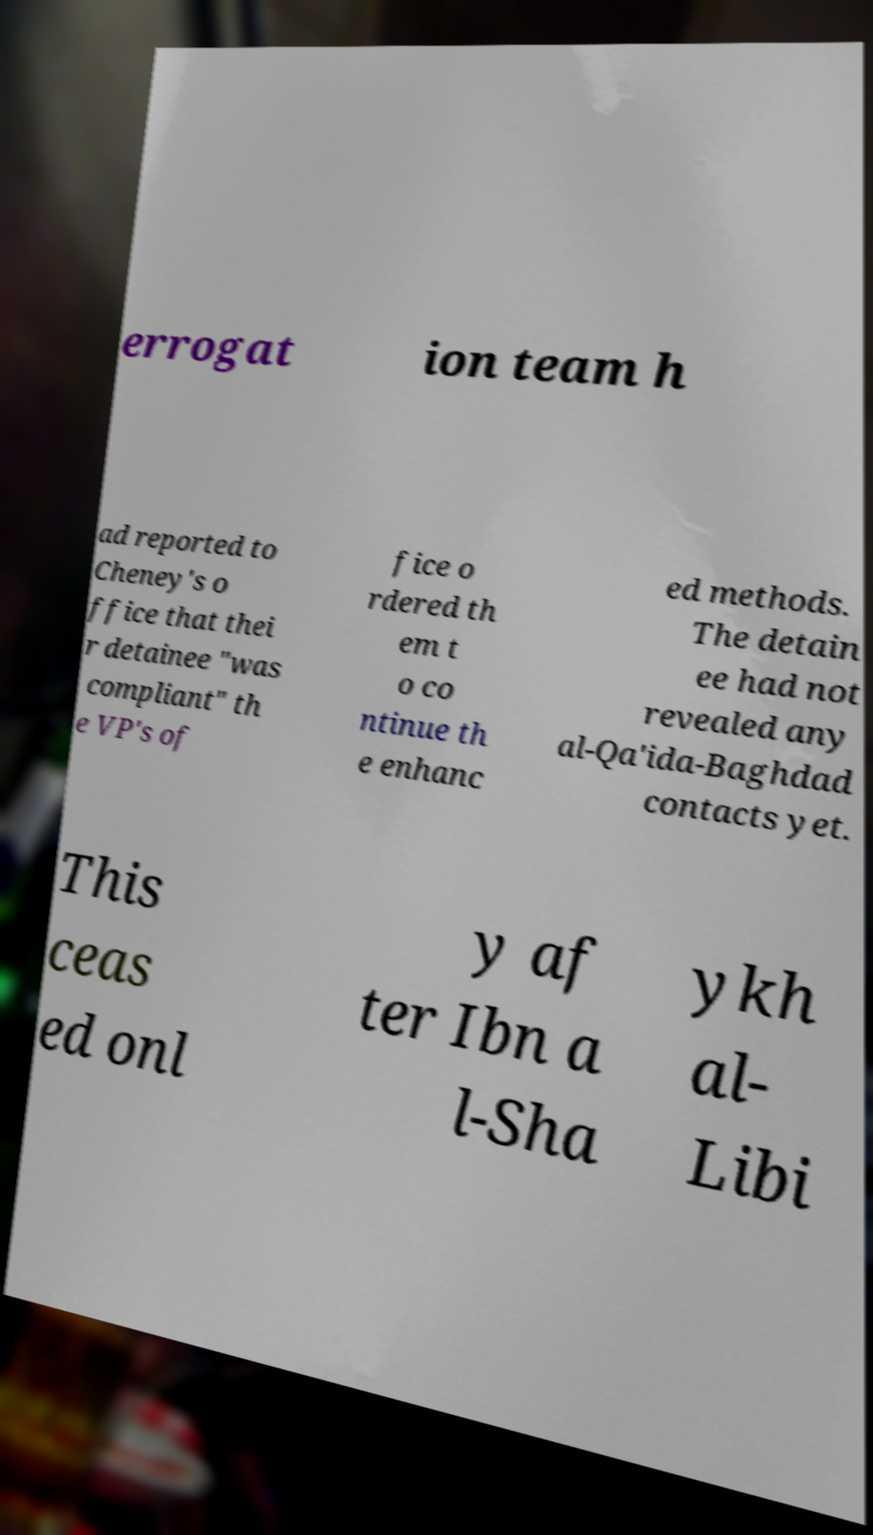Could you assist in decoding the text presented in this image and type it out clearly? errogat ion team h ad reported to Cheney's o ffice that thei r detainee "was compliant" th e VP's of fice o rdered th em t o co ntinue th e enhanc ed methods. The detain ee had not revealed any al-Qa'ida-Baghdad contacts yet. This ceas ed onl y af ter Ibn a l-Sha ykh al- Libi 